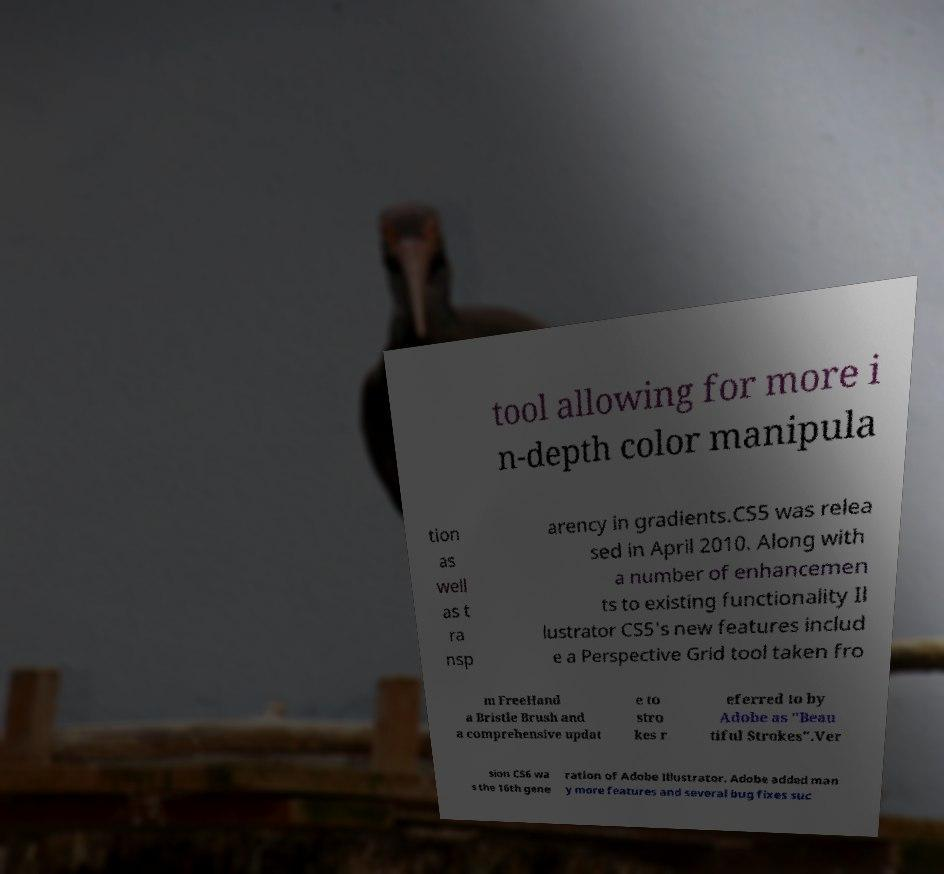Can you accurately transcribe the text from the provided image for me? tool allowing for more i n-depth color manipula tion as well as t ra nsp arency in gradients.CS5 was relea sed in April 2010. Along with a number of enhancemen ts to existing functionality Il lustrator CS5's new features includ e a Perspective Grid tool taken fro m FreeHand a Bristle Brush and a comprehensive updat e to stro kes r eferred to by Adobe as "Beau tiful Strokes".Ver sion CS6 wa s the 16th gene ration of Adobe Illustrator. Adobe added man y more features and several bug fixes suc 